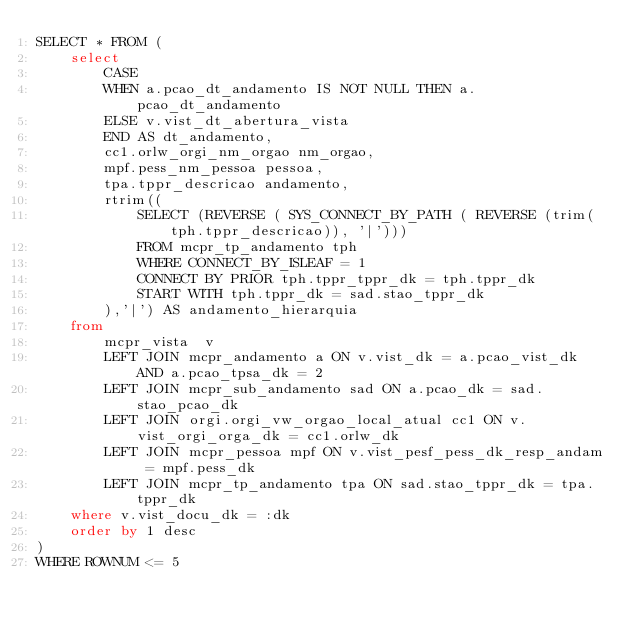<code> <loc_0><loc_0><loc_500><loc_500><_SQL_>SELECT * FROM (
    select
        CASE
        WHEN a.pcao_dt_andamento IS NOT NULL THEN a.pcao_dt_andamento
        ELSE v.vist_dt_abertura_vista
        END AS dt_andamento,
        cc1.orlw_orgi_nm_orgao nm_orgao,
        mpf.pess_nm_pessoa pessoa,
        tpa.tppr_descricao andamento,
        rtrim((
            SELECT (REVERSE ( SYS_CONNECT_BY_PATH ( REVERSE (trim(tph.tppr_descricao)), '|')))
            FROM mcpr_tp_andamento tph
            WHERE CONNECT_BY_ISLEAF = 1
            CONNECT BY PRIOR tph.tppr_tppr_dk = tph.tppr_dk
            START WITH tph.tppr_dk = sad.stao_tppr_dk
        ),'|') AS andamento_hierarquia
    from
        mcpr_vista  v
        LEFT JOIN mcpr_andamento a ON v.vist_dk = a.pcao_vist_dk AND a.pcao_tpsa_dk = 2
        LEFT JOIN mcpr_sub_andamento sad ON a.pcao_dk = sad.stao_pcao_dk
        LEFT JOIN orgi.orgi_vw_orgao_local_atual cc1 ON v.vist_orgi_orga_dk = cc1.orlw_dk
        LEFT JOIN mcpr_pessoa mpf ON v.vist_pesf_pess_dk_resp_andam = mpf.pess_dk
        LEFT JOIN mcpr_tp_andamento tpa ON sad.stao_tppr_dk = tpa.tppr_dk
    where v.vist_docu_dk = :dk
    order by 1 desc
)
WHERE ROWNUM <= 5</code> 